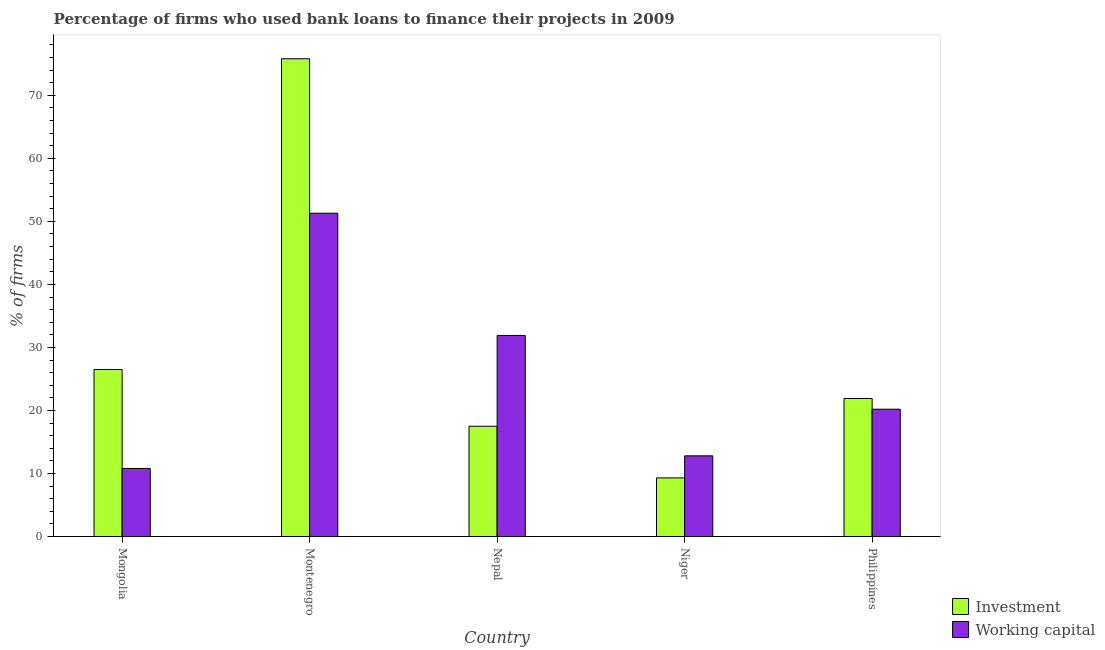How many groups of bars are there?
Your answer should be very brief. 5. Are the number of bars per tick equal to the number of legend labels?
Ensure brevity in your answer.  Yes. Are the number of bars on each tick of the X-axis equal?
Your answer should be very brief. Yes. How many bars are there on the 1st tick from the left?
Your response must be concise. 2. What is the label of the 5th group of bars from the left?
Your answer should be compact. Philippines. What is the percentage of firms using banks to finance working capital in Mongolia?
Offer a very short reply. 10.8. Across all countries, what is the maximum percentage of firms using banks to finance working capital?
Offer a terse response. 51.3. In which country was the percentage of firms using banks to finance investment maximum?
Give a very brief answer. Montenegro. In which country was the percentage of firms using banks to finance investment minimum?
Provide a succinct answer. Niger. What is the total percentage of firms using banks to finance investment in the graph?
Provide a succinct answer. 151. What is the difference between the percentage of firms using banks to finance investment in Nepal and that in Niger?
Offer a terse response. 8.2. What is the difference between the percentage of firms using banks to finance working capital in Nepal and the percentage of firms using banks to finance investment in Mongolia?
Make the answer very short. 5.4. What is the average percentage of firms using banks to finance investment per country?
Your answer should be very brief. 30.2. What is the difference between the percentage of firms using banks to finance working capital and percentage of firms using banks to finance investment in Mongolia?
Offer a very short reply. -15.7. What is the ratio of the percentage of firms using banks to finance investment in Mongolia to that in Philippines?
Keep it short and to the point. 1.21. Is the percentage of firms using banks to finance working capital in Niger less than that in Philippines?
Your answer should be very brief. Yes. Is the difference between the percentage of firms using banks to finance investment in Nepal and Niger greater than the difference between the percentage of firms using banks to finance working capital in Nepal and Niger?
Make the answer very short. No. What is the difference between the highest and the lowest percentage of firms using banks to finance working capital?
Your answer should be compact. 40.5. In how many countries, is the percentage of firms using banks to finance investment greater than the average percentage of firms using banks to finance investment taken over all countries?
Your response must be concise. 1. What does the 1st bar from the left in Nepal represents?
Provide a short and direct response. Investment. What does the 1st bar from the right in Philippines represents?
Offer a very short reply. Working capital. How many bars are there?
Ensure brevity in your answer.  10. Are all the bars in the graph horizontal?
Give a very brief answer. No. Are the values on the major ticks of Y-axis written in scientific E-notation?
Your answer should be very brief. No. Where does the legend appear in the graph?
Ensure brevity in your answer.  Bottom right. What is the title of the graph?
Give a very brief answer. Percentage of firms who used bank loans to finance their projects in 2009. Does "Broad money growth" appear as one of the legend labels in the graph?
Your answer should be compact. No. What is the label or title of the X-axis?
Provide a succinct answer. Country. What is the label or title of the Y-axis?
Provide a short and direct response. % of firms. What is the % of firms of Investment in Montenegro?
Your answer should be compact. 75.8. What is the % of firms of Working capital in Montenegro?
Make the answer very short. 51.3. What is the % of firms in Working capital in Nepal?
Your answer should be compact. 31.9. What is the % of firms of Investment in Philippines?
Provide a succinct answer. 21.9. What is the % of firms of Working capital in Philippines?
Give a very brief answer. 20.2. Across all countries, what is the maximum % of firms in Investment?
Make the answer very short. 75.8. Across all countries, what is the maximum % of firms of Working capital?
Offer a terse response. 51.3. What is the total % of firms of Investment in the graph?
Your answer should be compact. 151. What is the total % of firms of Working capital in the graph?
Provide a short and direct response. 127. What is the difference between the % of firms in Investment in Mongolia and that in Montenegro?
Keep it short and to the point. -49.3. What is the difference between the % of firms of Working capital in Mongolia and that in Montenegro?
Give a very brief answer. -40.5. What is the difference between the % of firms of Investment in Mongolia and that in Nepal?
Make the answer very short. 9. What is the difference between the % of firms of Working capital in Mongolia and that in Nepal?
Your answer should be compact. -21.1. What is the difference between the % of firms of Investment in Mongolia and that in Niger?
Your response must be concise. 17.2. What is the difference between the % of firms in Investment in Mongolia and that in Philippines?
Keep it short and to the point. 4.6. What is the difference between the % of firms in Working capital in Mongolia and that in Philippines?
Ensure brevity in your answer.  -9.4. What is the difference between the % of firms in Investment in Montenegro and that in Nepal?
Offer a very short reply. 58.3. What is the difference between the % of firms in Investment in Montenegro and that in Niger?
Give a very brief answer. 66.5. What is the difference between the % of firms in Working capital in Montenegro and that in Niger?
Provide a short and direct response. 38.5. What is the difference between the % of firms of Investment in Montenegro and that in Philippines?
Offer a very short reply. 53.9. What is the difference between the % of firms in Working capital in Montenegro and that in Philippines?
Provide a short and direct response. 31.1. What is the difference between the % of firms of Investment in Nepal and that in Philippines?
Make the answer very short. -4.4. What is the difference between the % of firms in Working capital in Nepal and that in Philippines?
Your response must be concise. 11.7. What is the difference between the % of firms in Investment in Mongolia and the % of firms in Working capital in Montenegro?
Make the answer very short. -24.8. What is the difference between the % of firms of Investment in Mongolia and the % of firms of Working capital in Nepal?
Provide a succinct answer. -5.4. What is the difference between the % of firms in Investment in Montenegro and the % of firms in Working capital in Nepal?
Ensure brevity in your answer.  43.9. What is the difference between the % of firms in Investment in Montenegro and the % of firms in Working capital in Niger?
Provide a succinct answer. 63. What is the difference between the % of firms of Investment in Montenegro and the % of firms of Working capital in Philippines?
Your answer should be compact. 55.6. What is the difference between the % of firms of Investment in Nepal and the % of firms of Working capital in Philippines?
Make the answer very short. -2.7. What is the difference between the % of firms of Investment in Niger and the % of firms of Working capital in Philippines?
Provide a succinct answer. -10.9. What is the average % of firms in Investment per country?
Make the answer very short. 30.2. What is the average % of firms in Working capital per country?
Keep it short and to the point. 25.4. What is the difference between the % of firms in Investment and % of firms in Working capital in Mongolia?
Provide a succinct answer. 15.7. What is the difference between the % of firms of Investment and % of firms of Working capital in Montenegro?
Your answer should be compact. 24.5. What is the difference between the % of firms in Investment and % of firms in Working capital in Nepal?
Provide a succinct answer. -14.4. What is the difference between the % of firms of Investment and % of firms of Working capital in Niger?
Ensure brevity in your answer.  -3.5. What is the difference between the % of firms in Investment and % of firms in Working capital in Philippines?
Keep it short and to the point. 1.7. What is the ratio of the % of firms of Investment in Mongolia to that in Montenegro?
Give a very brief answer. 0.35. What is the ratio of the % of firms in Working capital in Mongolia to that in Montenegro?
Provide a short and direct response. 0.21. What is the ratio of the % of firms of Investment in Mongolia to that in Nepal?
Make the answer very short. 1.51. What is the ratio of the % of firms in Working capital in Mongolia to that in Nepal?
Provide a succinct answer. 0.34. What is the ratio of the % of firms of Investment in Mongolia to that in Niger?
Your answer should be very brief. 2.85. What is the ratio of the % of firms of Working capital in Mongolia to that in Niger?
Give a very brief answer. 0.84. What is the ratio of the % of firms of Investment in Mongolia to that in Philippines?
Make the answer very short. 1.21. What is the ratio of the % of firms in Working capital in Mongolia to that in Philippines?
Provide a succinct answer. 0.53. What is the ratio of the % of firms of Investment in Montenegro to that in Nepal?
Keep it short and to the point. 4.33. What is the ratio of the % of firms of Working capital in Montenegro to that in Nepal?
Your response must be concise. 1.61. What is the ratio of the % of firms in Investment in Montenegro to that in Niger?
Offer a very short reply. 8.15. What is the ratio of the % of firms in Working capital in Montenegro to that in Niger?
Keep it short and to the point. 4.01. What is the ratio of the % of firms in Investment in Montenegro to that in Philippines?
Provide a succinct answer. 3.46. What is the ratio of the % of firms of Working capital in Montenegro to that in Philippines?
Offer a terse response. 2.54. What is the ratio of the % of firms in Investment in Nepal to that in Niger?
Keep it short and to the point. 1.88. What is the ratio of the % of firms of Working capital in Nepal to that in Niger?
Ensure brevity in your answer.  2.49. What is the ratio of the % of firms of Investment in Nepal to that in Philippines?
Give a very brief answer. 0.8. What is the ratio of the % of firms in Working capital in Nepal to that in Philippines?
Keep it short and to the point. 1.58. What is the ratio of the % of firms in Investment in Niger to that in Philippines?
Provide a short and direct response. 0.42. What is the ratio of the % of firms of Working capital in Niger to that in Philippines?
Make the answer very short. 0.63. What is the difference between the highest and the second highest % of firms of Investment?
Keep it short and to the point. 49.3. What is the difference between the highest and the lowest % of firms of Investment?
Keep it short and to the point. 66.5. What is the difference between the highest and the lowest % of firms in Working capital?
Offer a very short reply. 40.5. 